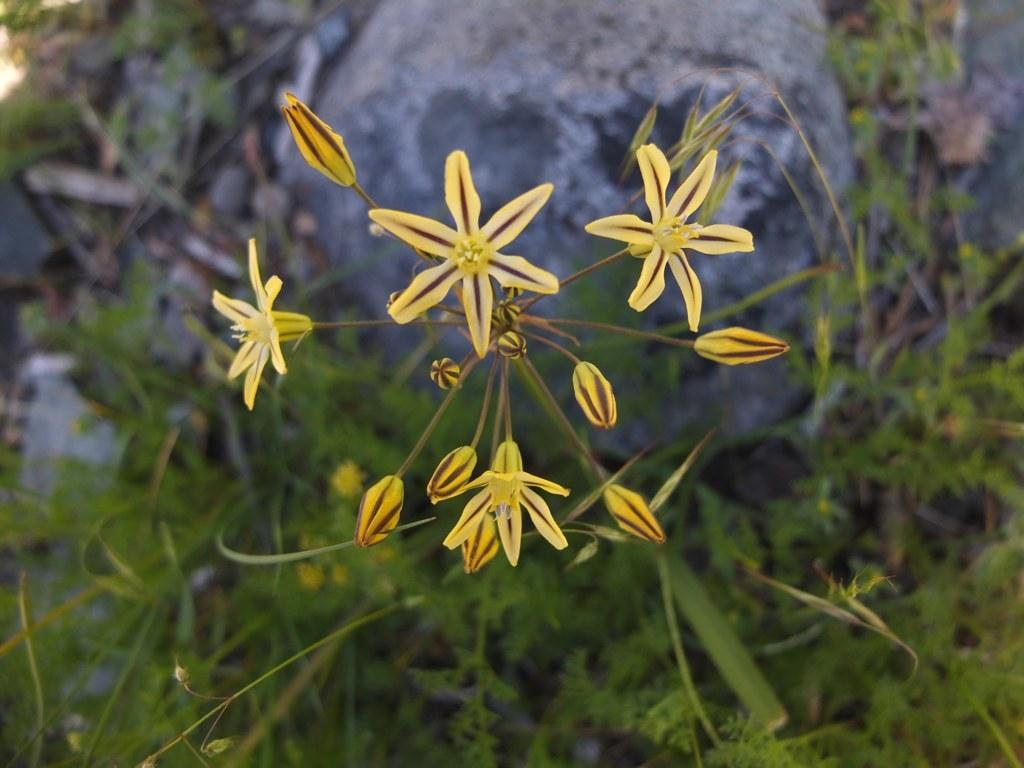What type of living organisms can be seen in the image? There are flowers and plants visible in the image. Can you describe the rock in the background of the image? Yes, there is a rock in the background of the image. What other elements can be seen in the image besides the flowers and plants? There is a rock in the background of the image. What type of headphones can be seen on the flowers in the image? There are no headphones present in the image; it features flowers, plants, and a rock. 